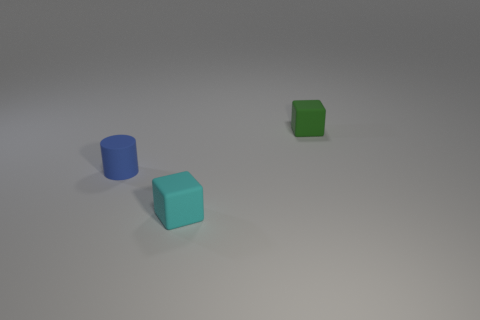Are there any large yellow matte cubes?
Your response must be concise. No. Is there any other thing that is the same shape as the tiny blue rubber object?
Your answer should be compact. No. What number of things are tiny cyan matte things that are in front of the cylinder or small cyan cubes?
Your answer should be very brief. 1. What number of objects are left of the rubber object that is right of the tiny cube that is in front of the blue thing?
Provide a short and direct response. 2. What shape is the tiny object left of the tiny object in front of the thing on the left side of the cyan rubber thing?
Your answer should be very brief. Cylinder. What number of other things are there of the same color as the small cylinder?
Provide a short and direct response. 0. What shape is the cyan thing in front of the block behind the tiny cylinder?
Offer a terse response. Cube. How many rubber things are in front of the blue rubber cylinder?
Offer a terse response. 1. Is there a small cylinder that has the same material as the tiny cyan cube?
Your answer should be compact. Yes. There is a green cube that is the same size as the cyan matte block; what is it made of?
Offer a terse response. Rubber. 